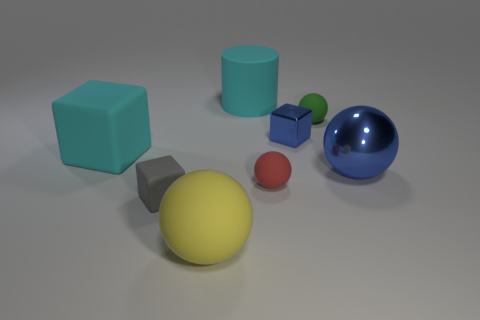Can you describe the sizes of all the objects relative to each other? Certainly! The largest object is the blue sphere, followed by the yellow sphere. The blue and green cubes are of the same size, ranking next. After them is the cyan cylinder, then the smaller red sphere, and finally, the smallest objects are the little green and blue spheres. 